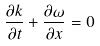Convert formula to latex. <formula><loc_0><loc_0><loc_500><loc_500>\frac { \partial k } { \partial t } + \frac { \partial \omega } { \partial x } = 0</formula> 